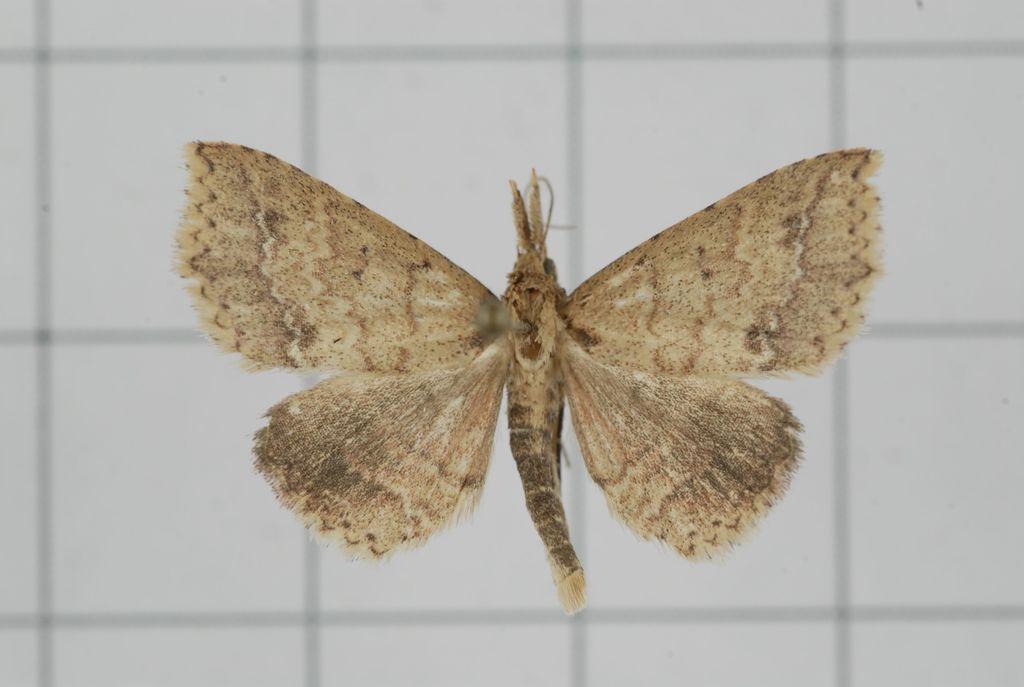Describe this image in one or two sentences. In this image there is a butterfly. There is a white color background. 